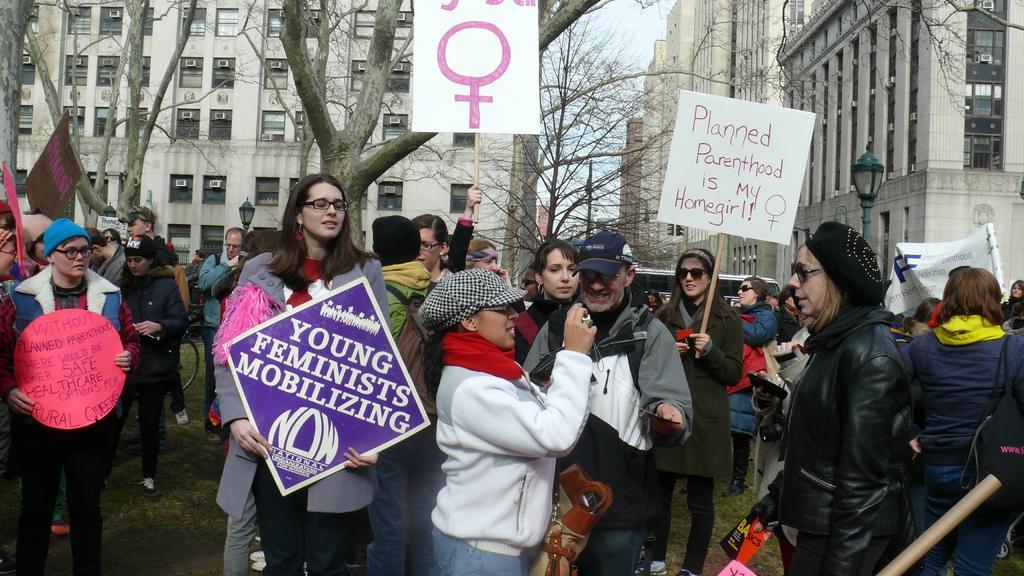In one or two sentences, can you explain what this image depicts? In this picture there are group of people standing and holding the placards and there is a person with white jacket is standing and holding the camera. At the back there are buildings and trees. At the top there is sky. 